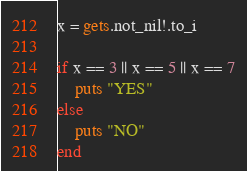<code> <loc_0><loc_0><loc_500><loc_500><_Crystal_>x = gets.not_nil!.to_i

if x == 3 || x == 5 || x == 7
    puts "YES"
else
    puts "NO"
end</code> 